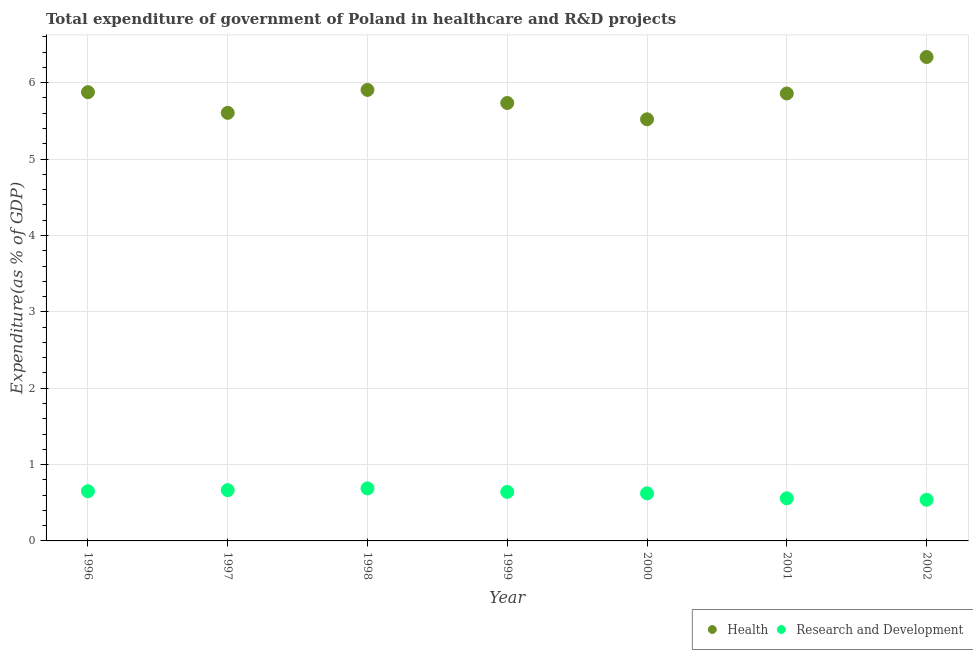Is the number of dotlines equal to the number of legend labels?
Keep it short and to the point. Yes. What is the expenditure in healthcare in 2002?
Keep it short and to the point. 6.34. Across all years, what is the maximum expenditure in r&d?
Offer a terse response. 0.69. Across all years, what is the minimum expenditure in healthcare?
Offer a terse response. 5.52. In which year was the expenditure in healthcare maximum?
Provide a short and direct response. 2002. In which year was the expenditure in r&d minimum?
Your answer should be very brief. 2002. What is the total expenditure in r&d in the graph?
Ensure brevity in your answer.  4.36. What is the difference between the expenditure in r&d in 1999 and that in 2002?
Your answer should be very brief. 0.1. What is the difference between the expenditure in healthcare in 2002 and the expenditure in r&d in 1996?
Make the answer very short. 5.69. What is the average expenditure in healthcare per year?
Ensure brevity in your answer.  5.83. In the year 2001, what is the difference between the expenditure in healthcare and expenditure in r&d?
Offer a terse response. 5.3. What is the ratio of the expenditure in healthcare in 1996 to that in 2001?
Offer a very short reply. 1. What is the difference between the highest and the second highest expenditure in healthcare?
Your answer should be very brief. 0.43. What is the difference between the highest and the lowest expenditure in r&d?
Your answer should be compact. 0.15. Does the expenditure in r&d monotonically increase over the years?
Make the answer very short. No. Is the expenditure in healthcare strictly greater than the expenditure in r&d over the years?
Make the answer very short. Yes. Is the expenditure in healthcare strictly less than the expenditure in r&d over the years?
Make the answer very short. No. How many dotlines are there?
Ensure brevity in your answer.  2. How many years are there in the graph?
Ensure brevity in your answer.  7. How many legend labels are there?
Your answer should be compact. 2. What is the title of the graph?
Ensure brevity in your answer.  Total expenditure of government of Poland in healthcare and R&D projects. What is the label or title of the Y-axis?
Offer a very short reply. Expenditure(as % of GDP). What is the Expenditure(as % of GDP) in Health in 1996?
Ensure brevity in your answer.  5.88. What is the Expenditure(as % of GDP) in Research and Development in 1996?
Your response must be concise. 0.65. What is the Expenditure(as % of GDP) in Health in 1997?
Give a very brief answer. 5.61. What is the Expenditure(as % of GDP) in Research and Development in 1997?
Offer a terse response. 0.66. What is the Expenditure(as % of GDP) in Health in 1998?
Keep it short and to the point. 5.91. What is the Expenditure(as % of GDP) of Research and Development in 1998?
Offer a very short reply. 0.69. What is the Expenditure(as % of GDP) of Health in 1999?
Offer a terse response. 5.73. What is the Expenditure(as % of GDP) of Research and Development in 1999?
Make the answer very short. 0.64. What is the Expenditure(as % of GDP) of Health in 2000?
Ensure brevity in your answer.  5.52. What is the Expenditure(as % of GDP) of Research and Development in 2000?
Ensure brevity in your answer.  0.62. What is the Expenditure(as % of GDP) of Health in 2001?
Your response must be concise. 5.86. What is the Expenditure(as % of GDP) in Research and Development in 2001?
Give a very brief answer. 0.56. What is the Expenditure(as % of GDP) of Health in 2002?
Your answer should be very brief. 6.34. What is the Expenditure(as % of GDP) in Research and Development in 2002?
Offer a terse response. 0.54. Across all years, what is the maximum Expenditure(as % of GDP) of Health?
Provide a short and direct response. 6.34. Across all years, what is the maximum Expenditure(as % of GDP) of Research and Development?
Make the answer very short. 0.69. Across all years, what is the minimum Expenditure(as % of GDP) in Health?
Offer a terse response. 5.52. Across all years, what is the minimum Expenditure(as % of GDP) of Research and Development?
Provide a short and direct response. 0.54. What is the total Expenditure(as % of GDP) of Health in the graph?
Offer a terse response. 40.84. What is the total Expenditure(as % of GDP) of Research and Development in the graph?
Offer a very short reply. 4.36. What is the difference between the Expenditure(as % of GDP) in Health in 1996 and that in 1997?
Ensure brevity in your answer.  0.27. What is the difference between the Expenditure(as % of GDP) in Research and Development in 1996 and that in 1997?
Keep it short and to the point. -0.01. What is the difference between the Expenditure(as % of GDP) in Health in 1996 and that in 1998?
Your answer should be very brief. -0.03. What is the difference between the Expenditure(as % of GDP) of Research and Development in 1996 and that in 1998?
Provide a short and direct response. -0.04. What is the difference between the Expenditure(as % of GDP) of Health in 1996 and that in 1999?
Offer a very short reply. 0.14. What is the difference between the Expenditure(as % of GDP) of Research and Development in 1996 and that in 1999?
Ensure brevity in your answer.  0.01. What is the difference between the Expenditure(as % of GDP) of Health in 1996 and that in 2000?
Your response must be concise. 0.36. What is the difference between the Expenditure(as % of GDP) of Research and Development in 1996 and that in 2000?
Ensure brevity in your answer.  0.03. What is the difference between the Expenditure(as % of GDP) of Health in 1996 and that in 2001?
Your answer should be very brief. 0.02. What is the difference between the Expenditure(as % of GDP) of Research and Development in 1996 and that in 2001?
Give a very brief answer. 0.09. What is the difference between the Expenditure(as % of GDP) of Health in 1996 and that in 2002?
Your response must be concise. -0.46. What is the difference between the Expenditure(as % of GDP) of Research and Development in 1996 and that in 2002?
Your response must be concise. 0.11. What is the difference between the Expenditure(as % of GDP) in Health in 1997 and that in 1998?
Your response must be concise. -0.3. What is the difference between the Expenditure(as % of GDP) of Research and Development in 1997 and that in 1998?
Provide a succinct answer. -0.02. What is the difference between the Expenditure(as % of GDP) in Health in 1997 and that in 1999?
Make the answer very short. -0.13. What is the difference between the Expenditure(as % of GDP) in Research and Development in 1997 and that in 1999?
Make the answer very short. 0.02. What is the difference between the Expenditure(as % of GDP) in Health in 1997 and that in 2000?
Offer a very short reply. 0.08. What is the difference between the Expenditure(as % of GDP) of Research and Development in 1997 and that in 2000?
Provide a succinct answer. 0.04. What is the difference between the Expenditure(as % of GDP) in Health in 1997 and that in 2001?
Your response must be concise. -0.25. What is the difference between the Expenditure(as % of GDP) of Research and Development in 1997 and that in 2001?
Offer a terse response. 0.11. What is the difference between the Expenditure(as % of GDP) in Health in 1997 and that in 2002?
Keep it short and to the point. -0.73. What is the difference between the Expenditure(as % of GDP) in Research and Development in 1997 and that in 2002?
Make the answer very short. 0.13. What is the difference between the Expenditure(as % of GDP) of Health in 1998 and that in 1999?
Provide a short and direct response. 0.17. What is the difference between the Expenditure(as % of GDP) of Research and Development in 1998 and that in 1999?
Provide a short and direct response. 0.05. What is the difference between the Expenditure(as % of GDP) in Health in 1998 and that in 2000?
Keep it short and to the point. 0.38. What is the difference between the Expenditure(as % of GDP) of Research and Development in 1998 and that in 2000?
Provide a short and direct response. 0.07. What is the difference between the Expenditure(as % of GDP) of Health in 1998 and that in 2001?
Your answer should be compact. 0.05. What is the difference between the Expenditure(as % of GDP) in Research and Development in 1998 and that in 2001?
Ensure brevity in your answer.  0.13. What is the difference between the Expenditure(as % of GDP) in Health in 1998 and that in 2002?
Your answer should be compact. -0.43. What is the difference between the Expenditure(as % of GDP) in Research and Development in 1998 and that in 2002?
Offer a terse response. 0.15. What is the difference between the Expenditure(as % of GDP) in Health in 1999 and that in 2000?
Your answer should be compact. 0.21. What is the difference between the Expenditure(as % of GDP) of Research and Development in 1999 and that in 2000?
Offer a very short reply. 0.02. What is the difference between the Expenditure(as % of GDP) in Health in 1999 and that in 2001?
Provide a succinct answer. -0.12. What is the difference between the Expenditure(as % of GDP) in Research and Development in 1999 and that in 2001?
Ensure brevity in your answer.  0.08. What is the difference between the Expenditure(as % of GDP) in Health in 1999 and that in 2002?
Keep it short and to the point. -0.6. What is the difference between the Expenditure(as % of GDP) of Research and Development in 1999 and that in 2002?
Ensure brevity in your answer.  0.1. What is the difference between the Expenditure(as % of GDP) in Health in 2000 and that in 2001?
Make the answer very short. -0.34. What is the difference between the Expenditure(as % of GDP) of Research and Development in 2000 and that in 2001?
Your response must be concise. 0.07. What is the difference between the Expenditure(as % of GDP) in Health in 2000 and that in 2002?
Your answer should be compact. -0.82. What is the difference between the Expenditure(as % of GDP) in Research and Development in 2000 and that in 2002?
Your answer should be compact. 0.08. What is the difference between the Expenditure(as % of GDP) in Health in 2001 and that in 2002?
Your response must be concise. -0.48. What is the difference between the Expenditure(as % of GDP) in Research and Development in 2001 and that in 2002?
Give a very brief answer. 0.02. What is the difference between the Expenditure(as % of GDP) in Health in 1996 and the Expenditure(as % of GDP) in Research and Development in 1997?
Your response must be concise. 5.21. What is the difference between the Expenditure(as % of GDP) in Health in 1996 and the Expenditure(as % of GDP) in Research and Development in 1998?
Make the answer very short. 5.19. What is the difference between the Expenditure(as % of GDP) in Health in 1996 and the Expenditure(as % of GDP) in Research and Development in 1999?
Your response must be concise. 5.23. What is the difference between the Expenditure(as % of GDP) of Health in 1996 and the Expenditure(as % of GDP) of Research and Development in 2000?
Give a very brief answer. 5.25. What is the difference between the Expenditure(as % of GDP) in Health in 1996 and the Expenditure(as % of GDP) in Research and Development in 2001?
Offer a very short reply. 5.32. What is the difference between the Expenditure(as % of GDP) in Health in 1996 and the Expenditure(as % of GDP) in Research and Development in 2002?
Give a very brief answer. 5.34. What is the difference between the Expenditure(as % of GDP) of Health in 1997 and the Expenditure(as % of GDP) of Research and Development in 1998?
Keep it short and to the point. 4.92. What is the difference between the Expenditure(as % of GDP) in Health in 1997 and the Expenditure(as % of GDP) in Research and Development in 1999?
Ensure brevity in your answer.  4.96. What is the difference between the Expenditure(as % of GDP) in Health in 1997 and the Expenditure(as % of GDP) in Research and Development in 2000?
Your answer should be very brief. 4.98. What is the difference between the Expenditure(as % of GDP) of Health in 1997 and the Expenditure(as % of GDP) of Research and Development in 2001?
Give a very brief answer. 5.05. What is the difference between the Expenditure(as % of GDP) in Health in 1997 and the Expenditure(as % of GDP) in Research and Development in 2002?
Make the answer very short. 5.07. What is the difference between the Expenditure(as % of GDP) in Health in 1998 and the Expenditure(as % of GDP) in Research and Development in 1999?
Provide a succinct answer. 5.26. What is the difference between the Expenditure(as % of GDP) of Health in 1998 and the Expenditure(as % of GDP) of Research and Development in 2000?
Keep it short and to the point. 5.28. What is the difference between the Expenditure(as % of GDP) in Health in 1998 and the Expenditure(as % of GDP) in Research and Development in 2001?
Your answer should be very brief. 5.35. What is the difference between the Expenditure(as % of GDP) of Health in 1998 and the Expenditure(as % of GDP) of Research and Development in 2002?
Your response must be concise. 5.37. What is the difference between the Expenditure(as % of GDP) of Health in 1999 and the Expenditure(as % of GDP) of Research and Development in 2000?
Provide a short and direct response. 5.11. What is the difference between the Expenditure(as % of GDP) in Health in 1999 and the Expenditure(as % of GDP) in Research and Development in 2001?
Keep it short and to the point. 5.18. What is the difference between the Expenditure(as % of GDP) of Health in 1999 and the Expenditure(as % of GDP) of Research and Development in 2002?
Give a very brief answer. 5.2. What is the difference between the Expenditure(as % of GDP) of Health in 2000 and the Expenditure(as % of GDP) of Research and Development in 2001?
Offer a very short reply. 4.96. What is the difference between the Expenditure(as % of GDP) in Health in 2000 and the Expenditure(as % of GDP) in Research and Development in 2002?
Offer a terse response. 4.98. What is the difference between the Expenditure(as % of GDP) in Health in 2001 and the Expenditure(as % of GDP) in Research and Development in 2002?
Offer a terse response. 5.32. What is the average Expenditure(as % of GDP) of Health per year?
Offer a terse response. 5.83. What is the average Expenditure(as % of GDP) in Research and Development per year?
Offer a terse response. 0.62. In the year 1996, what is the difference between the Expenditure(as % of GDP) of Health and Expenditure(as % of GDP) of Research and Development?
Make the answer very short. 5.23. In the year 1997, what is the difference between the Expenditure(as % of GDP) of Health and Expenditure(as % of GDP) of Research and Development?
Your response must be concise. 4.94. In the year 1998, what is the difference between the Expenditure(as % of GDP) of Health and Expenditure(as % of GDP) of Research and Development?
Make the answer very short. 5.22. In the year 1999, what is the difference between the Expenditure(as % of GDP) in Health and Expenditure(as % of GDP) in Research and Development?
Your response must be concise. 5.09. In the year 2000, what is the difference between the Expenditure(as % of GDP) in Health and Expenditure(as % of GDP) in Research and Development?
Provide a succinct answer. 4.9. In the year 2001, what is the difference between the Expenditure(as % of GDP) of Health and Expenditure(as % of GDP) of Research and Development?
Offer a very short reply. 5.3. In the year 2002, what is the difference between the Expenditure(as % of GDP) of Health and Expenditure(as % of GDP) of Research and Development?
Offer a terse response. 5.8. What is the ratio of the Expenditure(as % of GDP) in Health in 1996 to that in 1997?
Provide a short and direct response. 1.05. What is the ratio of the Expenditure(as % of GDP) in Research and Development in 1996 to that in 1997?
Your response must be concise. 0.98. What is the ratio of the Expenditure(as % of GDP) in Health in 1996 to that in 1998?
Your response must be concise. 0.99. What is the ratio of the Expenditure(as % of GDP) of Research and Development in 1996 to that in 1998?
Offer a terse response. 0.95. What is the ratio of the Expenditure(as % of GDP) of Health in 1996 to that in 1999?
Your answer should be very brief. 1.02. What is the ratio of the Expenditure(as % of GDP) in Research and Development in 1996 to that in 1999?
Ensure brevity in your answer.  1.01. What is the ratio of the Expenditure(as % of GDP) of Health in 1996 to that in 2000?
Provide a succinct answer. 1.06. What is the ratio of the Expenditure(as % of GDP) of Research and Development in 1996 to that in 2000?
Keep it short and to the point. 1.04. What is the ratio of the Expenditure(as % of GDP) in Health in 1996 to that in 2001?
Give a very brief answer. 1. What is the ratio of the Expenditure(as % of GDP) of Research and Development in 1996 to that in 2001?
Ensure brevity in your answer.  1.17. What is the ratio of the Expenditure(as % of GDP) in Health in 1996 to that in 2002?
Provide a succinct answer. 0.93. What is the ratio of the Expenditure(as % of GDP) in Research and Development in 1996 to that in 2002?
Your response must be concise. 1.21. What is the ratio of the Expenditure(as % of GDP) in Health in 1997 to that in 1998?
Make the answer very short. 0.95. What is the ratio of the Expenditure(as % of GDP) of Research and Development in 1997 to that in 1998?
Your answer should be very brief. 0.97. What is the ratio of the Expenditure(as % of GDP) in Health in 1997 to that in 1999?
Provide a succinct answer. 0.98. What is the ratio of the Expenditure(as % of GDP) in Research and Development in 1997 to that in 1999?
Ensure brevity in your answer.  1.04. What is the ratio of the Expenditure(as % of GDP) in Health in 1997 to that in 2000?
Provide a succinct answer. 1.02. What is the ratio of the Expenditure(as % of GDP) of Research and Development in 1997 to that in 2000?
Make the answer very short. 1.07. What is the ratio of the Expenditure(as % of GDP) in Health in 1997 to that in 2001?
Provide a short and direct response. 0.96. What is the ratio of the Expenditure(as % of GDP) in Research and Development in 1997 to that in 2001?
Offer a terse response. 1.19. What is the ratio of the Expenditure(as % of GDP) in Health in 1997 to that in 2002?
Your answer should be compact. 0.88. What is the ratio of the Expenditure(as % of GDP) in Research and Development in 1997 to that in 2002?
Offer a very short reply. 1.23. What is the ratio of the Expenditure(as % of GDP) in Health in 1998 to that in 1999?
Ensure brevity in your answer.  1.03. What is the ratio of the Expenditure(as % of GDP) in Research and Development in 1998 to that in 1999?
Your answer should be compact. 1.07. What is the ratio of the Expenditure(as % of GDP) in Health in 1998 to that in 2000?
Offer a very short reply. 1.07. What is the ratio of the Expenditure(as % of GDP) of Research and Development in 1998 to that in 2000?
Keep it short and to the point. 1.1. What is the ratio of the Expenditure(as % of GDP) of Health in 1998 to that in 2001?
Keep it short and to the point. 1.01. What is the ratio of the Expenditure(as % of GDP) of Research and Development in 1998 to that in 2001?
Offer a very short reply. 1.23. What is the ratio of the Expenditure(as % of GDP) in Health in 1998 to that in 2002?
Ensure brevity in your answer.  0.93. What is the ratio of the Expenditure(as % of GDP) in Research and Development in 1998 to that in 2002?
Offer a very short reply. 1.28. What is the ratio of the Expenditure(as % of GDP) of Health in 1999 to that in 2000?
Provide a succinct answer. 1.04. What is the ratio of the Expenditure(as % of GDP) in Research and Development in 1999 to that in 2000?
Provide a short and direct response. 1.03. What is the ratio of the Expenditure(as % of GDP) of Health in 1999 to that in 2001?
Provide a succinct answer. 0.98. What is the ratio of the Expenditure(as % of GDP) of Research and Development in 1999 to that in 2001?
Your answer should be compact. 1.15. What is the ratio of the Expenditure(as % of GDP) in Health in 1999 to that in 2002?
Offer a terse response. 0.91. What is the ratio of the Expenditure(as % of GDP) of Research and Development in 1999 to that in 2002?
Your answer should be compact. 1.19. What is the ratio of the Expenditure(as % of GDP) in Health in 2000 to that in 2001?
Your answer should be very brief. 0.94. What is the ratio of the Expenditure(as % of GDP) in Research and Development in 2000 to that in 2001?
Offer a very short reply. 1.12. What is the ratio of the Expenditure(as % of GDP) in Health in 2000 to that in 2002?
Ensure brevity in your answer.  0.87. What is the ratio of the Expenditure(as % of GDP) of Research and Development in 2000 to that in 2002?
Offer a very short reply. 1.16. What is the ratio of the Expenditure(as % of GDP) in Health in 2001 to that in 2002?
Ensure brevity in your answer.  0.92. What is the ratio of the Expenditure(as % of GDP) in Research and Development in 2001 to that in 2002?
Offer a terse response. 1.04. What is the difference between the highest and the second highest Expenditure(as % of GDP) in Health?
Your answer should be very brief. 0.43. What is the difference between the highest and the second highest Expenditure(as % of GDP) in Research and Development?
Provide a succinct answer. 0.02. What is the difference between the highest and the lowest Expenditure(as % of GDP) of Health?
Offer a very short reply. 0.82. What is the difference between the highest and the lowest Expenditure(as % of GDP) in Research and Development?
Ensure brevity in your answer.  0.15. 